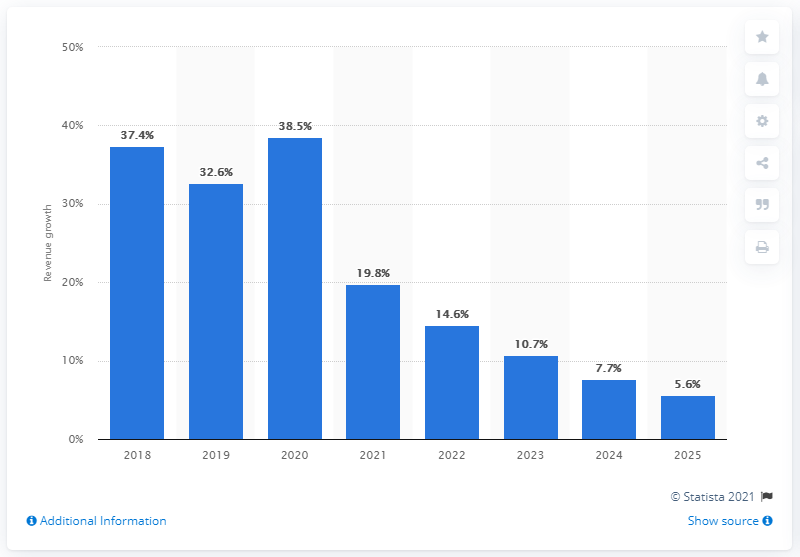Highlight a few significant elements in this photo. The growth forecast for India's eCommerce market in 2025 is expected to be 5.6%. 